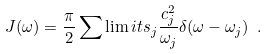Convert formula to latex. <formula><loc_0><loc_0><loc_500><loc_500>J ( \omega ) = \frac { \pi } { 2 } \sum \lim i t s _ { j } \frac { c _ { j } ^ { 2 } } { { \omega } _ { j } } \delta ( \omega - { \omega _ { j } } ) \ .</formula> 